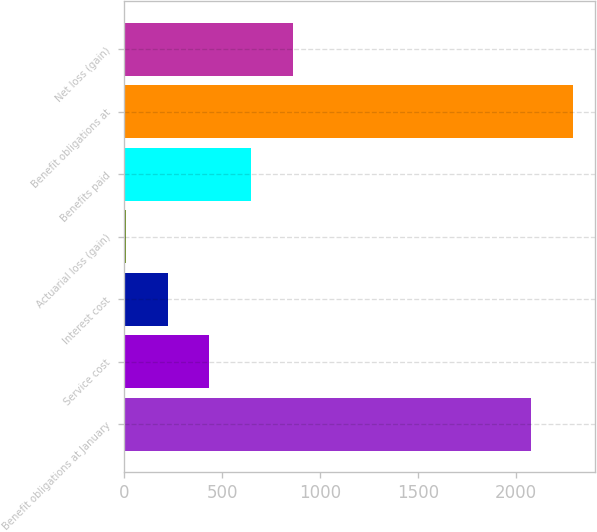<chart> <loc_0><loc_0><loc_500><loc_500><bar_chart><fcel>Benefit obligations at January<fcel>Service cost<fcel>Interest cost<fcel>Actuarial loss (gain)<fcel>Benefits paid<fcel>Benefit obligations at<fcel>Net loss (gain)<nl><fcel>2077<fcel>435<fcel>221.5<fcel>8<fcel>648.5<fcel>2290.5<fcel>862<nl></chart> 